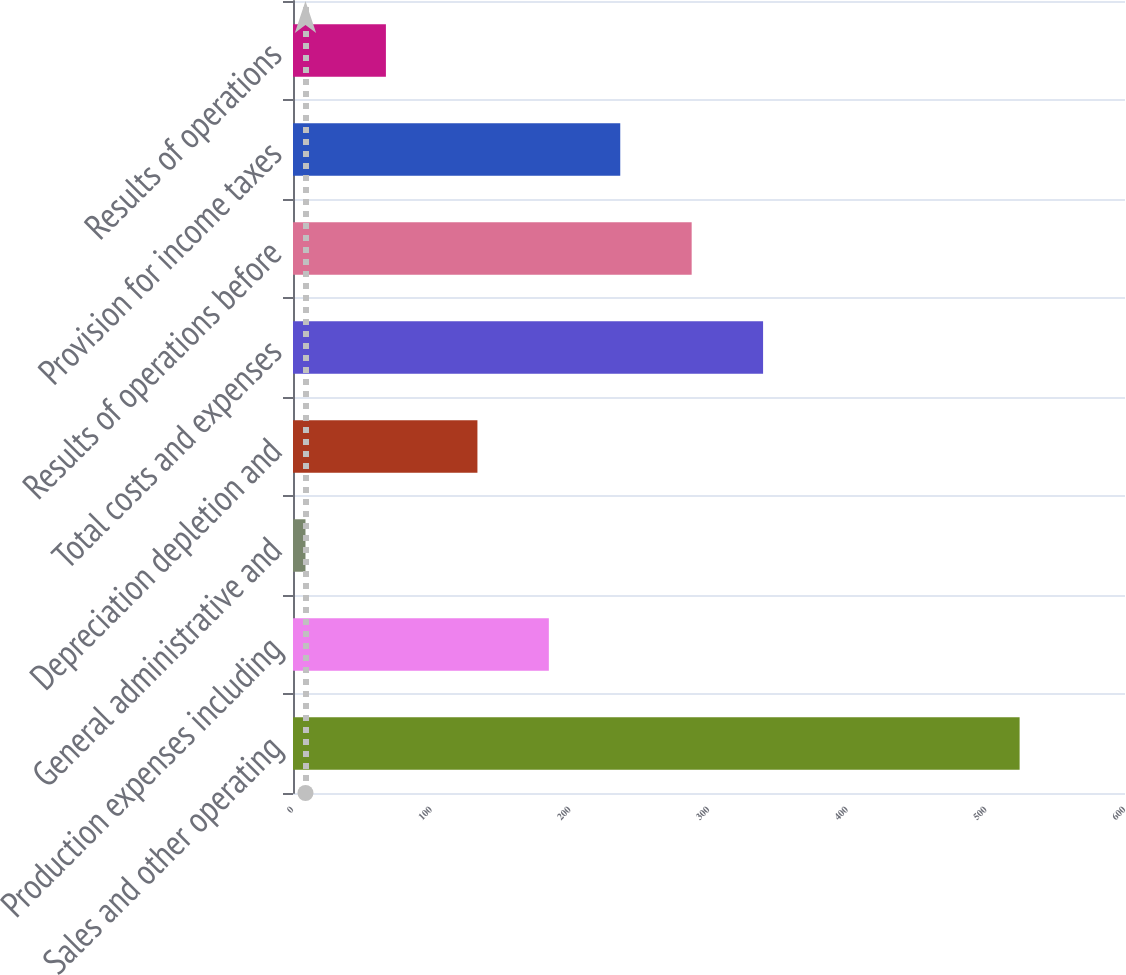Convert chart to OTSL. <chart><loc_0><loc_0><loc_500><loc_500><bar_chart><fcel>Sales and other operating<fcel>Production expenses including<fcel>General administrative and<fcel>Depreciation depletion and<fcel>Total costs and expenses<fcel>Results of operations before<fcel>Provision for income taxes<fcel>Results of operations<nl><fcel>524<fcel>184.5<fcel>9<fcel>133<fcel>339<fcel>287.5<fcel>236<fcel>67<nl></chart> 